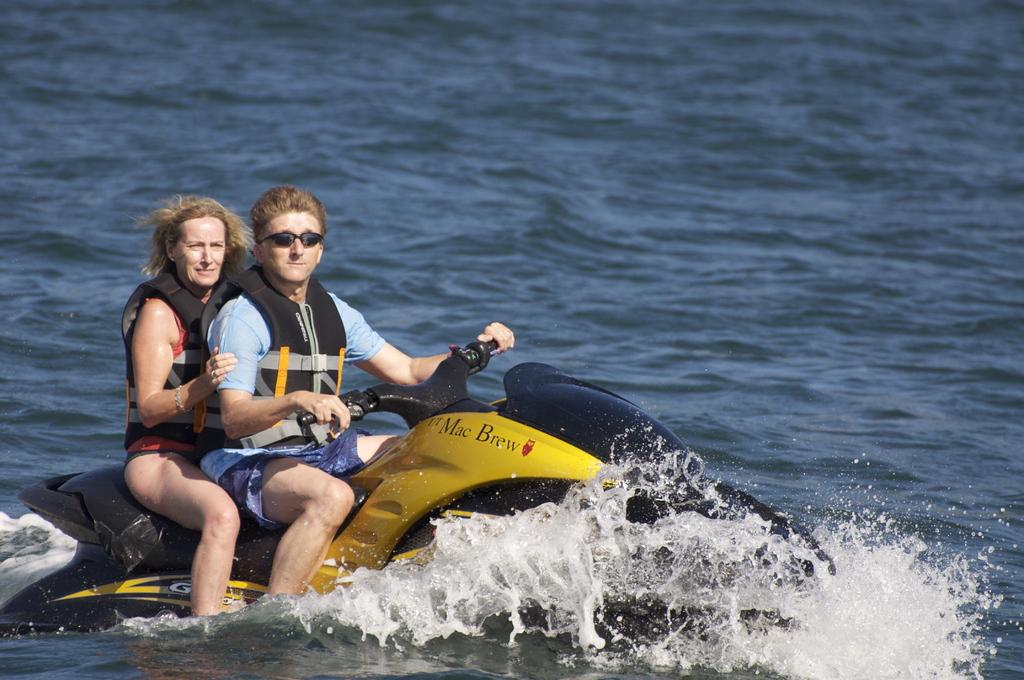Provide a one-sentence caption for the provided image. Couple riding on a jetski that is branded Mac Brew. 